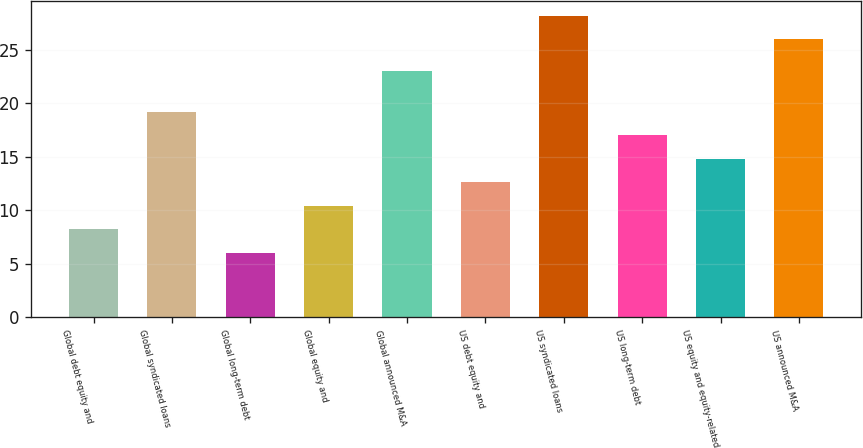Convert chart to OTSL. <chart><loc_0><loc_0><loc_500><loc_500><bar_chart><fcel>Global debt equity and<fcel>Global syndicated loans<fcel>Global long-term debt<fcel>Global equity and<fcel>Global announced M&A<fcel>US debt equity and<fcel>US syndicated loans<fcel>US long-term debt<fcel>US equity and equity-related<fcel>US announced M&A<nl><fcel>8.2<fcel>19.2<fcel>6<fcel>10.4<fcel>23<fcel>12.6<fcel>28.2<fcel>17<fcel>14.8<fcel>26<nl></chart> 